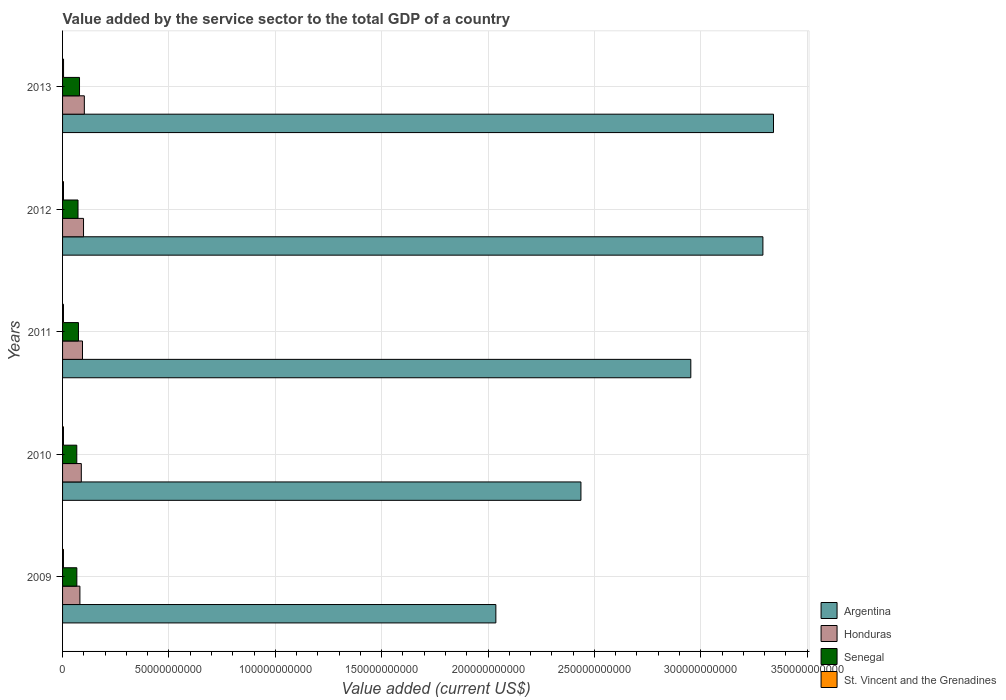How many bars are there on the 1st tick from the bottom?
Keep it short and to the point. 4. In how many cases, is the number of bars for a given year not equal to the number of legend labels?
Ensure brevity in your answer.  0. What is the value added by the service sector to the total GDP in Honduras in 2013?
Make the answer very short. 1.02e+1. Across all years, what is the maximum value added by the service sector to the total GDP in St. Vincent and the Grenadines?
Provide a succinct answer. 4.61e+08. Across all years, what is the minimum value added by the service sector to the total GDP in St. Vincent and the Grenadines?
Provide a short and direct response. 4.16e+08. In which year was the value added by the service sector to the total GDP in St. Vincent and the Grenadines maximum?
Your answer should be compact. 2013. In which year was the value added by the service sector to the total GDP in Argentina minimum?
Offer a terse response. 2009. What is the total value added by the service sector to the total GDP in St. Vincent and the Grenadines in the graph?
Your answer should be compact. 2.17e+09. What is the difference between the value added by the service sector to the total GDP in Senegal in 2009 and that in 2013?
Give a very brief answer. -1.26e+09. What is the difference between the value added by the service sector to the total GDP in Honduras in 2009 and the value added by the service sector to the total GDP in St. Vincent and the Grenadines in 2013?
Provide a short and direct response. 7.69e+09. What is the average value added by the service sector to the total GDP in Honduras per year?
Give a very brief answer. 9.29e+09. In the year 2012, what is the difference between the value added by the service sector to the total GDP in Senegal and value added by the service sector to the total GDP in Honduras?
Keep it short and to the point. -2.59e+09. What is the ratio of the value added by the service sector to the total GDP in Senegal in 2010 to that in 2013?
Provide a short and direct response. 0.84. Is the value added by the service sector to the total GDP in Senegal in 2010 less than that in 2011?
Provide a succinct answer. Yes. Is the difference between the value added by the service sector to the total GDP in Senegal in 2009 and 2012 greater than the difference between the value added by the service sector to the total GDP in Honduras in 2009 and 2012?
Provide a short and direct response. Yes. What is the difference between the highest and the second highest value added by the service sector to the total GDP in St. Vincent and the Grenadines?
Ensure brevity in your answer.  1.87e+07. What is the difference between the highest and the lowest value added by the service sector to the total GDP in Honduras?
Your answer should be compact. 2.08e+09. Is it the case that in every year, the sum of the value added by the service sector to the total GDP in Honduras and value added by the service sector to the total GDP in St. Vincent and the Grenadines is greater than the sum of value added by the service sector to the total GDP in Argentina and value added by the service sector to the total GDP in Senegal?
Offer a terse response. No. What does the 3rd bar from the top in 2010 represents?
Provide a succinct answer. Honduras. How many bars are there?
Offer a terse response. 20. How many years are there in the graph?
Keep it short and to the point. 5. What is the difference between two consecutive major ticks on the X-axis?
Provide a short and direct response. 5.00e+1. What is the title of the graph?
Your answer should be very brief. Value added by the service sector to the total GDP of a country. Does "Cuba" appear as one of the legend labels in the graph?
Make the answer very short. No. What is the label or title of the X-axis?
Ensure brevity in your answer.  Value added (current US$). What is the Value added (current US$) in Argentina in 2009?
Provide a succinct answer. 2.04e+11. What is the Value added (current US$) in Honduras in 2009?
Make the answer very short. 8.15e+09. What is the Value added (current US$) in Senegal in 2009?
Your answer should be compact. 6.71e+09. What is the Value added (current US$) in St. Vincent and the Grenadines in 2009?
Provide a succinct answer. 4.16e+08. What is the Value added (current US$) of Argentina in 2010?
Give a very brief answer. 2.44e+11. What is the Value added (current US$) in Honduras in 2010?
Make the answer very short. 8.81e+09. What is the Value added (current US$) in Senegal in 2010?
Provide a succinct answer. 6.68e+09. What is the Value added (current US$) in St. Vincent and the Grenadines in 2010?
Keep it short and to the point. 4.23e+08. What is the Value added (current US$) of Argentina in 2011?
Provide a short and direct response. 2.95e+11. What is the Value added (current US$) in Honduras in 2011?
Your answer should be very brief. 9.37e+09. What is the Value added (current US$) in Senegal in 2011?
Your answer should be compact. 7.47e+09. What is the Value added (current US$) in St. Vincent and the Grenadines in 2011?
Make the answer very short. 4.27e+08. What is the Value added (current US$) in Argentina in 2012?
Your response must be concise. 3.29e+11. What is the Value added (current US$) of Honduras in 2012?
Your answer should be compact. 9.86e+09. What is the Value added (current US$) of Senegal in 2012?
Ensure brevity in your answer.  7.26e+09. What is the Value added (current US$) of St. Vincent and the Grenadines in 2012?
Give a very brief answer. 4.42e+08. What is the Value added (current US$) of Argentina in 2013?
Make the answer very short. 3.34e+11. What is the Value added (current US$) of Honduras in 2013?
Offer a terse response. 1.02e+1. What is the Value added (current US$) of Senegal in 2013?
Offer a very short reply. 7.97e+09. What is the Value added (current US$) in St. Vincent and the Grenadines in 2013?
Keep it short and to the point. 4.61e+08. Across all years, what is the maximum Value added (current US$) of Argentina?
Keep it short and to the point. 3.34e+11. Across all years, what is the maximum Value added (current US$) of Honduras?
Give a very brief answer. 1.02e+1. Across all years, what is the maximum Value added (current US$) of Senegal?
Your answer should be very brief. 7.97e+09. Across all years, what is the maximum Value added (current US$) in St. Vincent and the Grenadines?
Offer a very short reply. 4.61e+08. Across all years, what is the minimum Value added (current US$) in Argentina?
Keep it short and to the point. 2.04e+11. Across all years, what is the minimum Value added (current US$) in Honduras?
Offer a terse response. 8.15e+09. Across all years, what is the minimum Value added (current US$) in Senegal?
Your answer should be compact. 6.68e+09. Across all years, what is the minimum Value added (current US$) in St. Vincent and the Grenadines?
Offer a very short reply. 4.16e+08. What is the total Value added (current US$) of Argentina in the graph?
Your response must be concise. 1.41e+12. What is the total Value added (current US$) in Honduras in the graph?
Provide a succinct answer. 4.64e+1. What is the total Value added (current US$) of Senegal in the graph?
Provide a short and direct response. 3.61e+1. What is the total Value added (current US$) in St. Vincent and the Grenadines in the graph?
Provide a short and direct response. 2.17e+09. What is the difference between the Value added (current US$) in Argentina in 2009 and that in 2010?
Your answer should be very brief. -4.00e+1. What is the difference between the Value added (current US$) of Honduras in 2009 and that in 2010?
Ensure brevity in your answer.  -6.55e+08. What is the difference between the Value added (current US$) in Senegal in 2009 and that in 2010?
Keep it short and to the point. 2.83e+07. What is the difference between the Value added (current US$) in St. Vincent and the Grenadines in 2009 and that in 2010?
Keep it short and to the point. -6.89e+06. What is the difference between the Value added (current US$) of Argentina in 2009 and that in 2011?
Provide a succinct answer. -9.16e+1. What is the difference between the Value added (current US$) in Honduras in 2009 and that in 2011?
Provide a short and direct response. -1.22e+09. What is the difference between the Value added (current US$) in Senegal in 2009 and that in 2011?
Provide a succinct answer. -7.61e+08. What is the difference between the Value added (current US$) of St. Vincent and the Grenadines in 2009 and that in 2011?
Your answer should be compact. -1.12e+07. What is the difference between the Value added (current US$) in Argentina in 2009 and that in 2012?
Provide a succinct answer. -1.26e+11. What is the difference between the Value added (current US$) of Honduras in 2009 and that in 2012?
Offer a terse response. -1.70e+09. What is the difference between the Value added (current US$) of Senegal in 2009 and that in 2012?
Give a very brief answer. -5.53e+08. What is the difference between the Value added (current US$) in St. Vincent and the Grenadines in 2009 and that in 2012?
Your answer should be very brief. -2.62e+07. What is the difference between the Value added (current US$) of Argentina in 2009 and that in 2013?
Offer a very short reply. -1.31e+11. What is the difference between the Value added (current US$) of Honduras in 2009 and that in 2013?
Give a very brief answer. -2.08e+09. What is the difference between the Value added (current US$) in Senegal in 2009 and that in 2013?
Keep it short and to the point. -1.26e+09. What is the difference between the Value added (current US$) of St. Vincent and the Grenadines in 2009 and that in 2013?
Offer a very short reply. -4.49e+07. What is the difference between the Value added (current US$) of Argentina in 2010 and that in 2011?
Provide a short and direct response. -5.17e+1. What is the difference between the Value added (current US$) in Honduras in 2010 and that in 2011?
Ensure brevity in your answer.  -5.61e+08. What is the difference between the Value added (current US$) of Senegal in 2010 and that in 2011?
Offer a very short reply. -7.90e+08. What is the difference between the Value added (current US$) in St. Vincent and the Grenadines in 2010 and that in 2011?
Make the answer very short. -4.36e+06. What is the difference between the Value added (current US$) in Argentina in 2010 and that in 2012?
Ensure brevity in your answer.  -8.55e+1. What is the difference between the Value added (current US$) in Honduras in 2010 and that in 2012?
Offer a very short reply. -1.05e+09. What is the difference between the Value added (current US$) in Senegal in 2010 and that in 2012?
Offer a terse response. -5.81e+08. What is the difference between the Value added (current US$) of St. Vincent and the Grenadines in 2010 and that in 2012?
Give a very brief answer. -1.93e+07. What is the difference between the Value added (current US$) in Argentina in 2010 and that in 2013?
Make the answer very short. -9.05e+1. What is the difference between the Value added (current US$) of Honduras in 2010 and that in 2013?
Your response must be concise. -1.43e+09. What is the difference between the Value added (current US$) in Senegal in 2010 and that in 2013?
Keep it short and to the point. -1.29e+09. What is the difference between the Value added (current US$) in St. Vincent and the Grenadines in 2010 and that in 2013?
Your response must be concise. -3.80e+07. What is the difference between the Value added (current US$) of Argentina in 2011 and that in 2012?
Keep it short and to the point. -3.39e+1. What is the difference between the Value added (current US$) in Honduras in 2011 and that in 2012?
Give a very brief answer. -4.86e+08. What is the difference between the Value added (current US$) of Senegal in 2011 and that in 2012?
Keep it short and to the point. 2.08e+08. What is the difference between the Value added (current US$) of St. Vincent and the Grenadines in 2011 and that in 2012?
Your answer should be compact. -1.50e+07. What is the difference between the Value added (current US$) in Argentina in 2011 and that in 2013?
Provide a succinct answer. -3.89e+1. What is the difference between the Value added (current US$) of Honduras in 2011 and that in 2013?
Ensure brevity in your answer.  -8.67e+08. What is the difference between the Value added (current US$) in Senegal in 2011 and that in 2013?
Your answer should be very brief. -4.97e+08. What is the difference between the Value added (current US$) of St. Vincent and the Grenadines in 2011 and that in 2013?
Your response must be concise. -3.37e+07. What is the difference between the Value added (current US$) of Argentina in 2012 and that in 2013?
Your answer should be very brief. -4.99e+09. What is the difference between the Value added (current US$) in Honduras in 2012 and that in 2013?
Provide a succinct answer. -3.81e+08. What is the difference between the Value added (current US$) in Senegal in 2012 and that in 2013?
Offer a very short reply. -7.06e+08. What is the difference between the Value added (current US$) in St. Vincent and the Grenadines in 2012 and that in 2013?
Make the answer very short. -1.87e+07. What is the difference between the Value added (current US$) of Argentina in 2009 and the Value added (current US$) of Honduras in 2010?
Make the answer very short. 1.95e+11. What is the difference between the Value added (current US$) of Argentina in 2009 and the Value added (current US$) of Senegal in 2010?
Your answer should be very brief. 1.97e+11. What is the difference between the Value added (current US$) of Argentina in 2009 and the Value added (current US$) of St. Vincent and the Grenadines in 2010?
Your answer should be compact. 2.03e+11. What is the difference between the Value added (current US$) of Honduras in 2009 and the Value added (current US$) of Senegal in 2010?
Give a very brief answer. 1.47e+09. What is the difference between the Value added (current US$) of Honduras in 2009 and the Value added (current US$) of St. Vincent and the Grenadines in 2010?
Provide a succinct answer. 7.73e+09. What is the difference between the Value added (current US$) in Senegal in 2009 and the Value added (current US$) in St. Vincent and the Grenadines in 2010?
Provide a succinct answer. 6.29e+09. What is the difference between the Value added (current US$) in Argentina in 2009 and the Value added (current US$) in Honduras in 2011?
Your answer should be compact. 1.94e+11. What is the difference between the Value added (current US$) in Argentina in 2009 and the Value added (current US$) in Senegal in 2011?
Provide a short and direct response. 1.96e+11. What is the difference between the Value added (current US$) of Argentina in 2009 and the Value added (current US$) of St. Vincent and the Grenadines in 2011?
Give a very brief answer. 2.03e+11. What is the difference between the Value added (current US$) of Honduras in 2009 and the Value added (current US$) of Senegal in 2011?
Your response must be concise. 6.83e+08. What is the difference between the Value added (current US$) of Honduras in 2009 and the Value added (current US$) of St. Vincent and the Grenadines in 2011?
Make the answer very short. 7.73e+09. What is the difference between the Value added (current US$) in Senegal in 2009 and the Value added (current US$) in St. Vincent and the Grenadines in 2011?
Keep it short and to the point. 6.28e+09. What is the difference between the Value added (current US$) in Argentina in 2009 and the Value added (current US$) in Honduras in 2012?
Keep it short and to the point. 1.94e+11. What is the difference between the Value added (current US$) in Argentina in 2009 and the Value added (current US$) in Senegal in 2012?
Your answer should be compact. 1.96e+11. What is the difference between the Value added (current US$) of Argentina in 2009 and the Value added (current US$) of St. Vincent and the Grenadines in 2012?
Keep it short and to the point. 2.03e+11. What is the difference between the Value added (current US$) of Honduras in 2009 and the Value added (current US$) of Senegal in 2012?
Keep it short and to the point. 8.92e+08. What is the difference between the Value added (current US$) of Honduras in 2009 and the Value added (current US$) of St. Vincent and the Grenadines in 2012?
Your response must be concise. 7.71e+09. What is the difference between the Value added (current US$) of Senegal in 2009 and the Value added (current US$) of St. Vincent and the Grenadines in 2012?
Your answer should be very brief. 6.27e+09. What is the difference between the Value added (current US$) in Argentina in 2009 and the Value added (current US$) in Honduras in 2013?
Keep it short and to the point. 1.93e+11. What is the difference between the Value added (current US$) of Argentina in 2009 and the Value added (current US$) of Senegal in 2013?
Your response must be concise. 1.96e+11. What is the difference between the Value added (current US$) of Argentina in 2009 and the Value added (current US$) of St. Vincent and the Grenadines in 2013?
Ensure brevity in your answer.  2.03e+11. What is the difference between the Value added (current US$) of Honduras in 2009 and the Value added (current US$) of Senegal in 2013?
Ensure brevity in your answer.  1.86e+08. What is the difference between the Value added (current US$) in Honduras in 2009 and the Value added (current US$) in St. Vincent and the Grenadines in 2013?
Provide a succinct answer. 7.69e+09. What is the difference between the Value added (current US$) of Senegal in 2009 and the Value added (current US$) of St. Vincent and the Grenadines in 2013?
Keep it short and to the point. 6.25e+09. What is the difference between the Value added (current US$) of Argentina in 2010 and the Value added (current US$) of Honduras in 2011?
Your answer should be compact. 2.34e+11. What is the difference between the Value added (current US$) in Argentina in 2010 and the Value added (current US$) in Senegal in 2011?
Offer a very short reply. 2.36e+11. What is the difference between the Value added (current US$) of Argentina in 2010 and the Value added (current US$) of St. Vincent and the Grenadines in 2011?
Provide a succinct answer. 2.43e+11. What is the difference between the Value added (current US$) in Honduras in 2010 and the Value added (current US$) in Senegal in 2011?
Your response must be concise. 1.34e+09. What is the difference between the Value added (current US$) of Honduras in 2010 and the Value added (current US$) of St. Vincent and the Grenadines in 2011?
Ensure brevity in your answer.  8.38e+09. What is the difference between the Value added (current US$) in Senegal in 2010 and the Value added (current US$) in St. Vincent and the Grenadines in 2011?
Provide a short and direct response. 6.25e+09. What is the difference between the Value added (current US$) of Argentina in 2010 and the Value added (current US$) of Honduras in 2012?
Ensure brevity in your answer.  2.34e+11. What is the difference between the Value added (current US$) in Argentina in 2010 and the Value added (current US$) in Senegal in 2012?
Make the answer very short. 2.36e+11. What is the difference between the Value added (current US$) of Argentina in 2010 and the Value added (current US$) of St. Vincent and the Grenadines in 2012?
Ensure brevity in your answer.  2.43e+11. What is the difference between the Value added (current US$) of Honduras in 2010 and the Value added (current US$) of Senegal in 2012?
Make the answer very short. 1.55e+09. What is the difference between the Value added (current US$) of Honduras in 2010 and the Value added (current US$) of St. Vincent and the Grenadines in 2012?
Ensure brevity in your answer.  8.37e+09. What is the difference between the Value added (current US$) in Senegal in 2010 and the Value added (current US$) in St. Vincent and the Grenadines in 2012?
Your response must be concise. 6.24e+09. What is the difference between the Value added (current US$) in Argentina in 2010 and the Value added (current US$) in Honduras in 2013?
Give a very brief answer. 2.33e+11. What is the difference between the Value added (current US$) in Argentina in 2010 and the Value added (current US$) in Senegal in 2013?
Provide a short and direct response. 2.36e+11. What is the difference between the Value added (current US$) in Argentina in 2010 and the Value added (current US$) in St. Vincent and the Grenadines in 2013?
Give a very brief answer. 2.43e+11. What is the difference between the Value added (current US$) of Honduras in 2010 and the Value added (current US$) of Senegal in 2013?
Your response must be concise. 8.41e+08. What is the difference between the Value added (current US$) in Honduras in 2010 and the Value added (current US$) in St. Vincent and the Grenadines in 2013?
Provide a short and direct response. 8.35e+09. What is the difference between the Value added (current US$) of Senegal in 2010 and the Value added (current US$) of St. Vincent and the Grenadines in 2013?
Your answer should be compact. 6.22e+09. What is the difference between the Value added (current US$) in Argentina in 2011 and the Value added (current US$) in Honduras in 2012?
Your response must be concise. 2.85e+11. What is the difference between the Value added (current US$) of Argentina in 2011 and the Value added (current US$) of Senegal in 2012?
Offer a terse response. 2.88e+11. What is the difference between the Value added (current US$) of Argentina in 2011 and the Value added (current US$) of St. Vincent and the Grenadines in 2012?
Your response must be concise. 2.95e+11. What is the difference between the Value added (current US$) in Honduras in 2011 and the Value added (current US$) in Senegal in 2012?
Provide a short and direct response. 2.11e+09. What is the difference between the Value added (current US$) of Honduras in 2011 and the Value added (current US$) of St. Vincent and the Grenadines in 2012?
Provide a succinct answer. 8.93e+09. What is the difference between the Value added (current US$) in Senegal in 2011 and the Value added (current US$) in St. Vincent and the Grenadines in 2012?
Your answer should be compact. 7.03e+09. What is the difference between the Value added (current US$) of Argentina in 2011 and the Value added (current US$) of Honduras in 2013?
Provide a short and direct response. 2.85e+11. What is the difference between the Value added (current US$) in Argentina in 2011 and the Value added (current US$) in Senegal in 2013?
Ensure brevity in your answer.  2.87e+11. What is the difference between the Value added (current US$) of Argentina in 2011 and the Value added (current US$) of St. Vincent and the Grenadines in 2013?
Ensure brevity in your answer.  2.95e+11. What is the difference between the Value added (current US$) of Honduras in 2011 and the Value added (current US$) of Senegal in 2013?
Keep it short and to the point. 1.40e+09. What is the difference between the Value added (current US$) of Honduras in 2011 and the Value added (current US$) of St. Vincent and the Grenadines in 2013?
Offer a very short reply. 8.91e+09. What is the difference between the Value added (current US$) of Senegal in 2011 and the Value added (current US$) of St. Vincent and the Grenadines in 2013?
Offer a very short reply. 7.01e+09. What is the difference between the Value added (current US$) of Argentina in 2012 and the Value added (current US$) of Honduras in 2013?
Your response must be concise. 3.19e+11. What is the difference between the Value added (current US$) in Argentina in 2012 and the Value added (current US$) in Senegal in 2013?
Offer a terse response. 3.21e+11. What is the difference between the Value added (current US$) of Argentina in 2012 and the Value added (current US$) of St. Vincent and the Grenadines in 2013?
Ensure brevity in your answer.  3.29e+11. What is the difference between the Value added (current US$) in Honduras in 2012 and the Value added (current US$) in Senegal in 2013?
Your answer should be very brief. 1.89e+09. What is the difference between the Value added (current US$) in Honduras in 2012 and the Value added (current US$) in St. Vincent and the Grenadines in 2013?
Ensure brevity in your answer.  9.40e+09. What is the difference between the Value added (current US$) of Senegal in 2012 and the Value added (current US$) of St. Vincent and the Grenadines in 2013?
Your answer should be very brief. 6.80e+09. What is the average Value added (current US$) of Argentina per year?
Offer a very short reply. 2.81e+11. What is the average Value added (current US$) of Honduras per year?
Provide a short and direct response. 9.29e+09. What is the average Value added (current US$) of Senegal per year?
Provide a succinct answer. 7.22e+09. What is the average Value added (current US$) of St. Vincent and the Grenadines per year?
Your response must be concise. 4.34e+08. In the year 2009, what is the difference between the Value added (current US$) in Argentina and Value added (current US$) in Honduras?
Provide a succinct answer. 1.96e+11. In the year 2009, what is the difference between the Value added (current US$) of Argentina and Value added (current US$) of Senegal?
Your answer should be compact. 1.97e+11. In the year 2009, what is the difference between the Value added (current US$) of Argentina and Value added (current US$) of St. Vincent and the Grenadines?
Provide a succinct answer. 2.03e+11. In the year 2009, what is the difference between the Value added (current US$) of Honduras and Value added (current US$) of Senegal?
Offer a terse response. 1.44e+09. In the year 2009, what is the difference between the Value added (current US$) in Honduras and Value added (current US$) in St. Vincent and the Grenadines?
Offer a very short reply. 7.74e+09. In the year 2009, what is the difference between the Value added (current US$) in Senegal and Value added (current US$) in St. Vincent and the Grenadines?
Give a very brief answer. 6.29e+09. In the year 2010, what is the difference between the Value added (current US$) in Argentina and Value added (current US$) in Honduras?
Your answer should be very brief. 2.35e+11. In the year 2010, what is the difference between the Value added (current US$) of Argentina and Value added (current US$) of Senegal?
Offer a very short reply. 2.37e+11. In the year 2010, what is the difference between the Value added (current US$) in Argentina and Value added (current US$) in St. Vincent and the Grenadines?
Your response must be concise. 2.43e+11. In the year 2010, what is the difference between the Value added (current US$) of Honduras and Value added (current US$) of Senegal?
Give a very brief answer. 2.13e+09. In the year 2010, what is the difference between the Value added (current US$) of Honduras and Value added (current US$) of St. Vincent and the Grenadines?
Keep it short and to the point. 8.39e+09. In the year 2010, what is the difference between the Value added (current US$) in Senegal and Value added (current US$) in St. Vincent and the Grenadines?
Provide a short and direct response. 6.26e+09. In the year 2011, what is the difference between the Value added (current US$) in Argentina and Value added (current US$) in Honduras?
Offer a very short reply. 2.86e+11. In the year 2011, what is the difference between the Value added (current US$) of Argentina and Value added (current US$) of Senegal?
Give a very brief answer. 2.88e+11. In the year 2011, what is the difference between the Value added (current US$) of Argentina and Value added (current US$) of St. Vincent and the Grenadines?
Your answer should be very brief. 2.95e+11. In the year 2011, what is the difference between the Value added (current US$) in Honduras and Value added (current US$) in Senegal?
Make the answer very short. 1.90e+09. In the year 2011, what is the difference between the Value added (current US$) in Honduras and Value added (current US$) in St. Vincent and the Grenadines?
Offer a terse response. 8.94e+09. In the year 2011, what is the difference between the Value added (current US$) in Senegal and Value added (current US$) in St. Vincent and the Grenadines?
Make the answer very short. 7.04e+09. In the year 2012, what is the difference between the Value added (current US$) in Argentina and Value added (current US$) in Honduras?
Provide a succinct answer. 3.19e+11. In the year 2012, what is the difference between the Value added (current US$) of Argentina and Value added (current US$) of Senegal?
Provide a succinct answer. 3.22e+11. In the year 2012, what is the difference between the Value added (current US$) of Argentina and Value added (current US$) of St. Vincent and the Grenadines?
Provide a succinct answer. 3.29e+11. In the year 2012, what is the difference between the Value added (current US$) of Honduras and Value added (current US$) of Senegal?
Ensure brevity in your answer.  2.59e+09. In the year 2012, what is the difference between the Value added (current US$) of Honduras and Value added (current US$) of St. Vincent and the Grenadines?
Make the answer very short. 9.41e+09. In the year 2012, what is the difference between the Value added (current US$) of Senegal and Value added (current US$) of St. Vincent and the Grenadines?
Offer a very short reply. 6.82e+09. In the year 2013, what is the difference between the Value added (current US$) of Argentina and Value added (current US$) of Honduras?
Your response must be concise. 3.24e+11. In the year 2013, what is the difference between the Value added (current US$) in Argentina and Value added (current US$) in Senegal?
Provide a short and direct response. 3.26e+11. In the year 2013, what is the difference between the Value added (current US$) in Argentina and Value added (current US$) in St. Vincent and the Grenadines?
Offer a very short reply. 3.34e+11. In the year 2013, what is the difference between the Value added (current US$) in Honduras and Value added (current US$) in Senegal?
Your answer should be very brief. 2.27e+09. In the year 2013, what is the difference between the Value added (current US$) of Honduras and Value added (current US$) of St. Vincent and the Grenadines?
Ensure brevity in your answer.  9.78e+09. In the year 2013, what is the difference between the Value added (current US$) in Senegal and Value added (current US$) in St. Vincent and the Grenadines?
Provide a short and direct response. 7.51e+09. What is the ratio of the Value added (current US$) of Argentina in 2009 to that in 2010?
Ensure brevity in your answer.  0.84. What is the ratio of the Value added (current US$) of Honduras in 2009 to that in 2010?
Offer a very short reply. 0.93. What is the ratio of the Value added (current US$) of St. Vincent and the Grenadines in 2009 to that in 2010?
Make the answer very short. 0.98. What is the ratio of the Value added (current US$) in Argentina in 2009 to that in 2011?
Keep it short and to the point. 0.69. What is the ratio of the Value added (current US$) of Honduras in 2009 to that in 2011?
Offer a terse response. 0.87. What is the ratio of the Value added (current US$) of Senegal in 2009 to that in 2011?
Provide a succinct answer. 0.9. What is the ratio of the Value added (current US$) of St. Vincent and the Grenadines in 2009 to that in 2011?
Your answer should be compact. 0.97. What is the ratio of the Value added (current US$) of Argentina in 2009 to that in 2012?
Your response must be concise. 0.62. What is the ratio of the Value added (current US$) of Honduras in 2009 to that in 2012?
Your answer should be very brief. 0.83. What is the ratio of the Value added (current US$) of Senegal in 2009 to that in 2012?
Provide a short and direct response. 0.92. What is the ratio of the Value added (current US$) in St. Vincent and the Grenadines in 2009 to that in 2012?
Offer a terse response. 0.94. What is the ratio of the Value added (current US$) in Argentina in 2009 to that in 2013?
Provide a succinct answer. 0.61. What is the ratio of the Value added (current US$) of Honduras in 2009 to that in 2013?
Make the answer very short. 0.8. What is the ratio of the Value added (current US$) of Senegal in 2009 to that in 2013?
Your answer should be compact. 0.84. What is the ratio of the Value added (current US$) of St. Vincent and the Grenadines in 2009 to that in 2013?
Give a very brief answer. 0.9. What is the ratio of the Value added (current US$) in Argentina in 2010 to that in 2011?
Keep it short and to the point. 0.83. What is the ratio of the Value added (current US$) of Honduras in 2010 to that in 2011?
Give a very brief answer. 0.94. What is the ratio of the Value added (current US$) in Senegal in 2010 to that in 2011?
Offer a very short reply. 0.89. What is the ratio of the Value added (current US$) of Argentina in 2010 to that in 2012?
Offer a terse response. 0.74. What is the ratio of the Value added (current US$) of Honduras in 2010 to that in 2012?
Give a very brief answer. 0.89. What is the ratio of the Value added (current US$) of Senegal in 2010 to that in 2012?
Offer a very short reply. 0.92. What is the ratio of the Value added (current US$) in St. Vincent and the Grenadines in 2010 to that in 2012?
Ensure brevity in your answer.  0.96. What is the ratio of the Value added (current US$) of Argentina in 2010 to that in 2013?
Provide a short and direct response. 0.73. What is the ratio of the Value added (current US$) in Honduras in 2010 to that in 2013?
Ensure brevity in your answer.  0.86. What is the ratio of the Value added (current US$) of Senegal in 2010 to that in 2013?
Ensure brevity in your answer.  0.84. What is the ratio of the Value added (current US$) in St. Vincent and the Grenadines in 2010 to that in 2013?
Ensure brevity in your answer.  0.92. What is the ratio of the Value added (current US$) of Argentina in 2011 to that in 2012?
Your response must be concise. 0.9. What is the ratio of the Value added (current US$) in Honduras in 2011 to that in 2012?
Keep it short and to the point. 0.95. What is the ratio of the Value added (current US$) of Senegal in 2011 to that in 2012?
Make the answer very short. 1.03. What is the ratio of the Value added (current US$) in St. Vincent and the Grenadines in 2011 to that in 2012?
Offer a very short reply. 0.97. What is the ratio of the Value added (current US$) in Argentina in 2011 to that in 2013?
Provide a succinct answer. 0.88. What is the ratio of the Value added (current US$) in Honduras in 2011 to that in 2013?
Your response must be concise. 0.92. What is the ratio of the Value added (current US$) of Senegal in 2011 to that in 2013?
Offer a very short reply. 0.94. What is the ratio of the Value added (current US$) of St. Vincent and the Grenadines in 2011 to that in 2013?
Offer a very short reply. 0.93. What is the ratio of the Value added (current US$) of Argentina in 2012 to that in 2013?
Your answer should be compact. 0.99. What is the ratio of the Value added (current US$) in Honduras in 2012 to that in 2013?
Your answer should be compact. 0.96. What is the ratio of the Value added (current US$) in Senegal in 2012 to that in 2013?
Offer a terse response. 0.91. What is the ratio of the Value added (current US$) in St. Vincent and the Grenadines in 2012 to that in 2013?
Your response must be concise. 0.96. What is the difference between the highest and the second highest Value added (current US$) of Argentina?
Your answer should be very brief. 4.99e+09. What is the difference between the highest and the second highest Value added (current US$) in Honduras?
Make the answer very short. 3.81e+08. What is the difference between the highest and the second highest Value added (current US$) of Senegal?
Make the answer very short. 4.97e+08. What is the difference between the highest and the second highest Value added (current US$) of St. Vincent and the Grenadines?
Offer a very short reply. 1.87e+07. What is the difference between the highest and the lowest Value added (current US$) in Argentina?
Make the answer very short. 1.31e+11. What is the difference between the highest and the lowest Value added (current US$) in Honduras?
Your answer should be very brief. 2.08e+09. What is the difference between the highest and the lowest Value added (current US$) in Senegal?
Your response must be concise. 1.29e+09. What is the difference between the highest and the lowest Value added (current US$) in St. Vincent and the Grenadines?
Your response must be concise. 4.49e+07. 